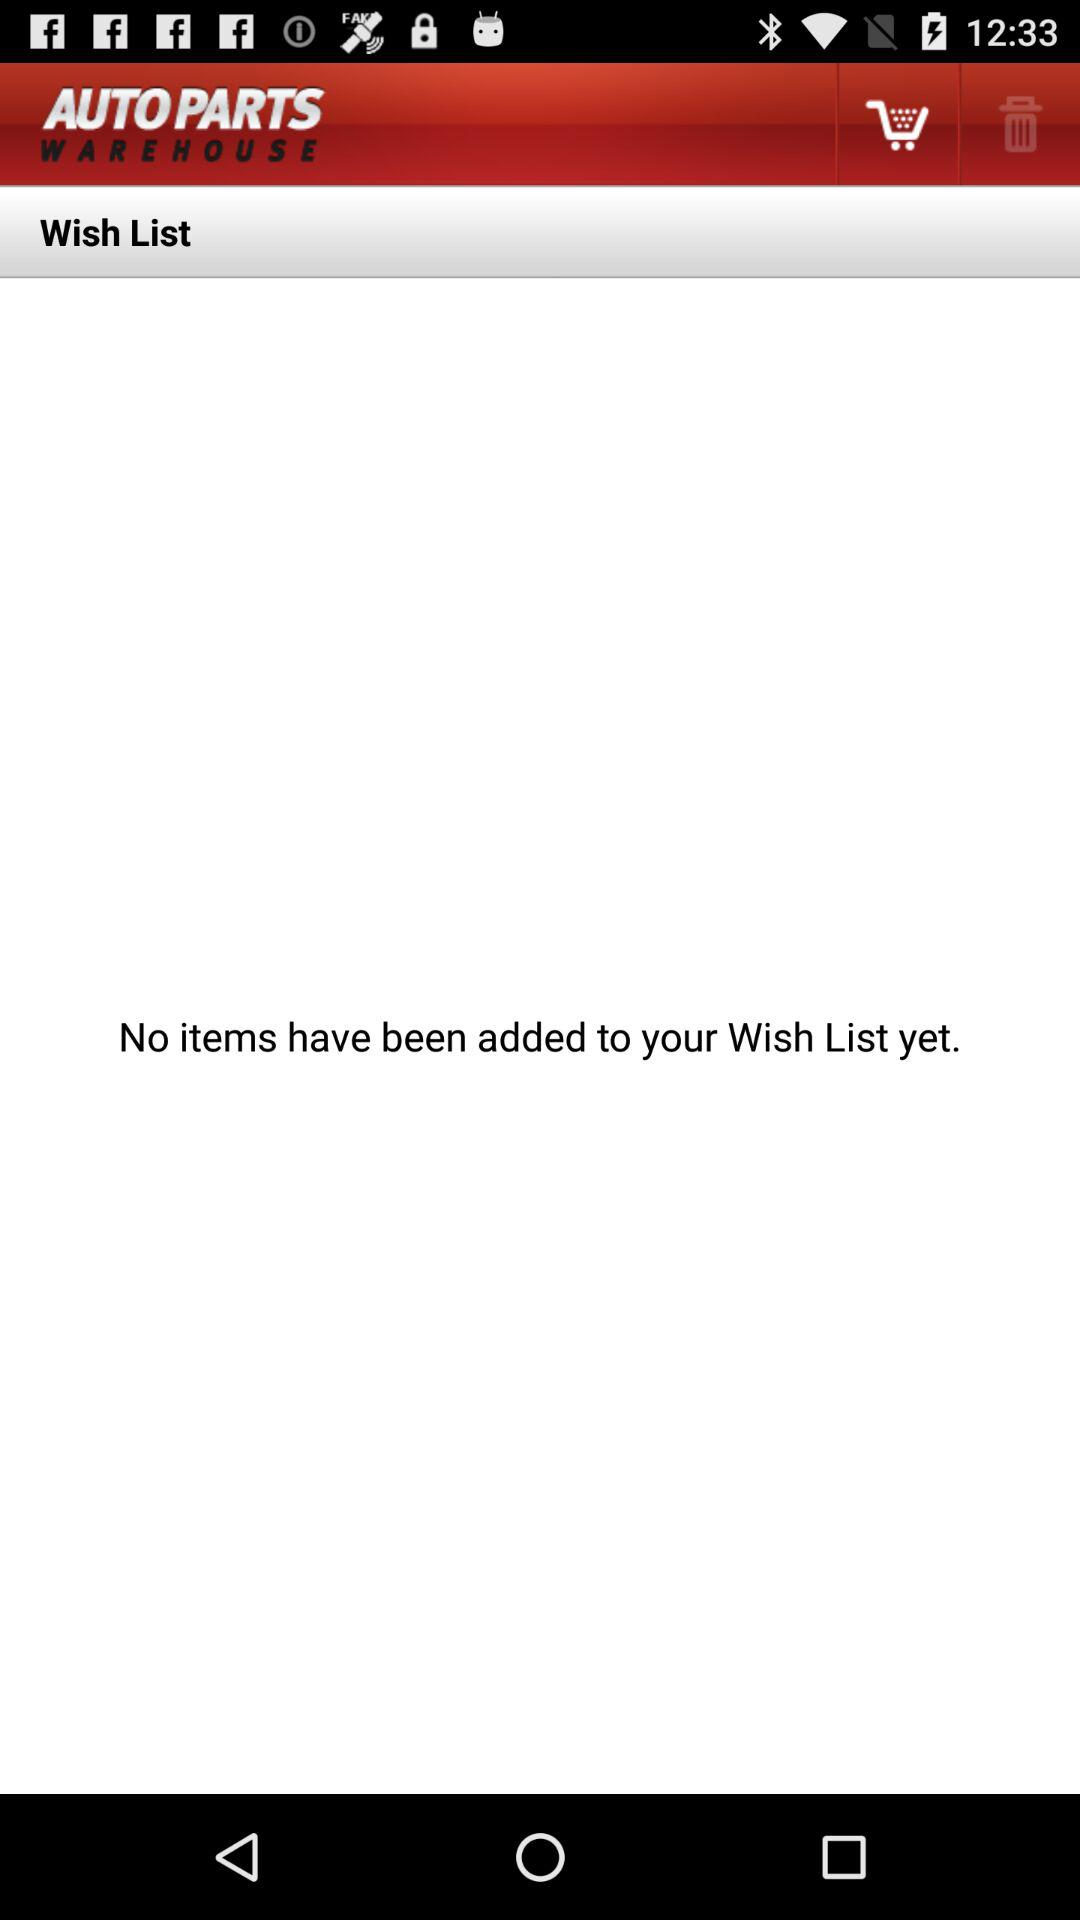What is the application name? The application name is "AUTO PARTS WAREHOUSE". 